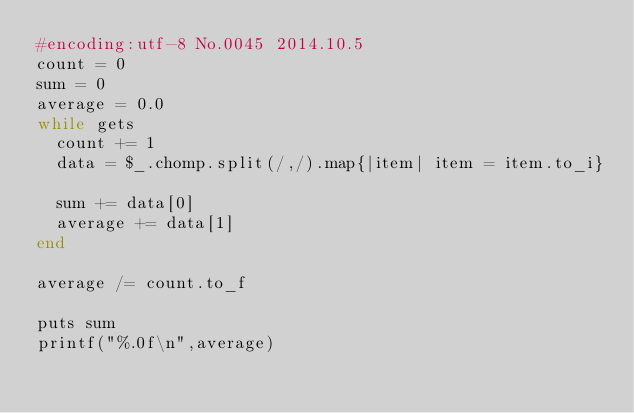<code> <loc_0><loc_0><loc_500><loc_500><_Ruby_>#encoding:utf-8 No.0045 2014.10.5
count = 0
sum = 0
average = 0.0
while gets
  count += 1
  data = $_.chomp.split(/,/).map{|item| item = item.to_i}

  sum += data[0]
  average += data[1]
end

average /= count.to_f

puts sum
printf("%.0f\n",average)</code> 